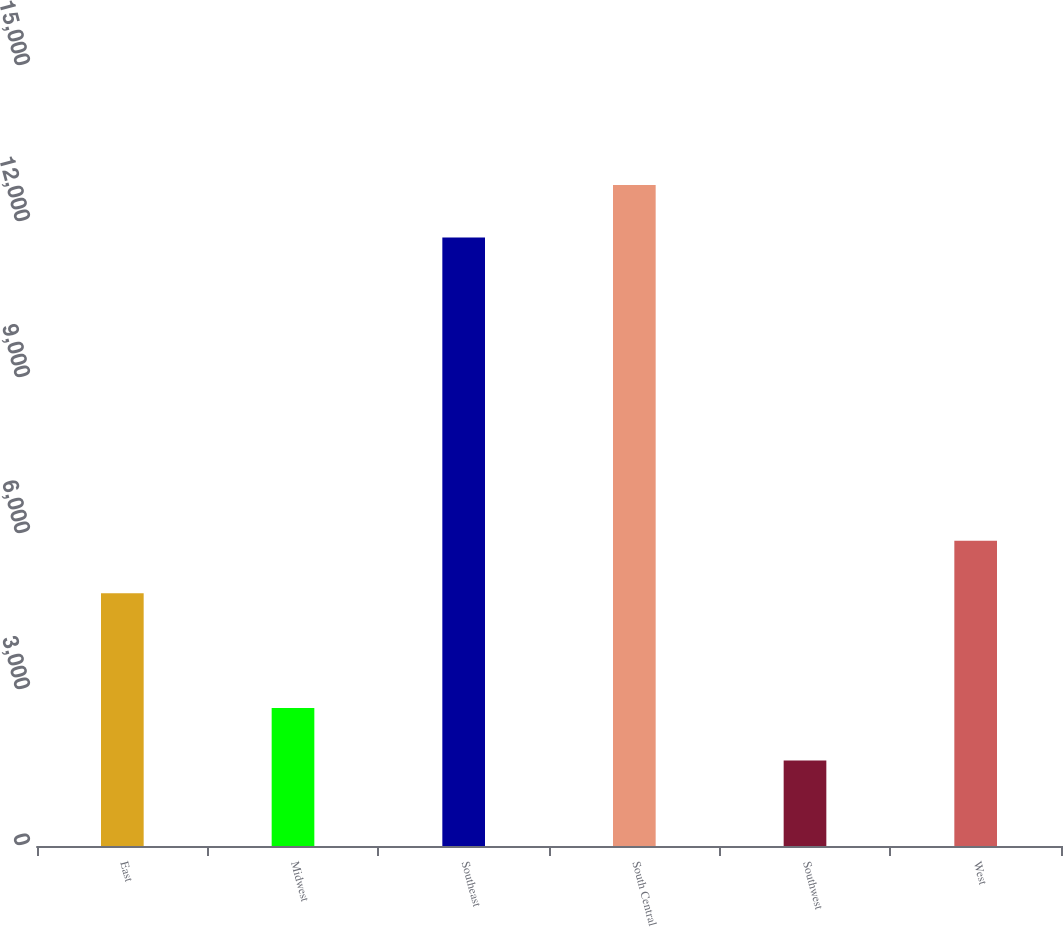Convert chart to OTSL. <chart><loc_0><loc_0><loc_500><loc_500><bar_chart><fcel>East<fcel>Midwest<fcel>Southeast<fcel>South Central<fcel>Southwest<fcel>West<nl><fcel>4859<fcel>2655.8<fcel>11703<fcel>12713.8<fcel>1645<fcel>5869.8<nl></chart> 